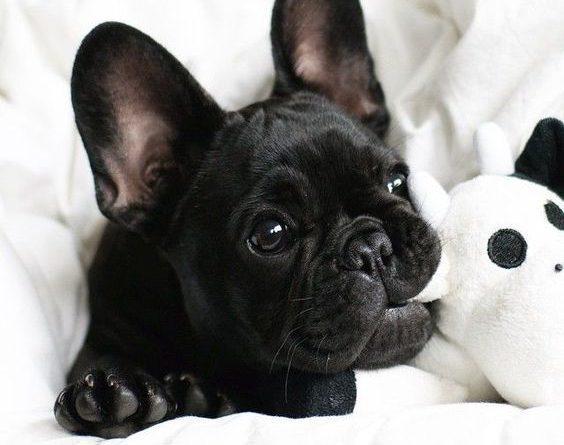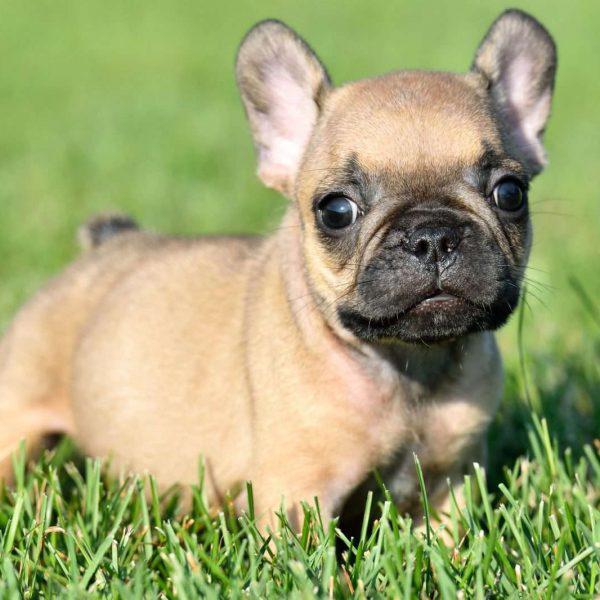The first image is the image on the left, the second image is the image on the right. For the images displayed, is the sentence "In one of the image the dog is on the grass." factually correct? Answer yes or no. Yes. The first image is the image on the left, the second image is the image on the right. Given the left and right images, does the statement "One of the dogs is biting a stuffed animal." hold true? Answer yes or no. Yes. 